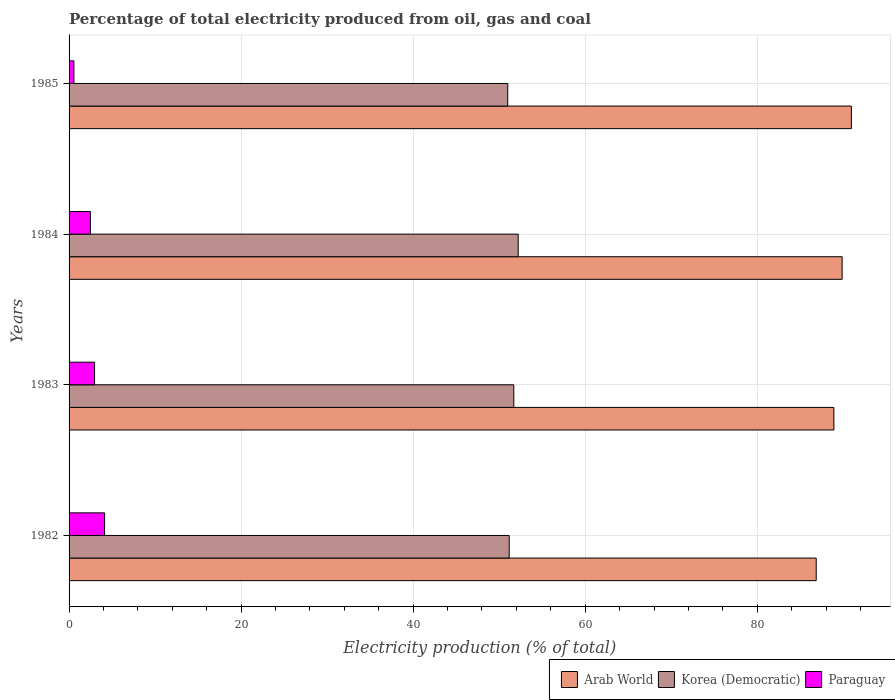How many groups of bars are there?
Give a very brief answer. 4. Are the number of bars per tick equal to the number of legend labels?
Your response must be concise. Yes. How many bars are there on the 4th tick from the bottom?
Offer a very short reply. 3. What is the label of the 4th group of bars from the top?
Make the answer very short. 1982. What is the electricity production in in Paraguay in 1982?
Give a very brief answer. 4.13. Across all years, what is the maximum electricity production in in Korea (Democratic)?
Give a very brief answer. 52.21. Across all years, what is the minimum electricity production in in Paraguay?
Make the answer very short. 0.56. In which year was the electricity production in in Arab World maximum?
Provide a succinct answer. 1985. In which year was the electricity production in in Paraguay minimum?
Provide a succinct answer. 1985. What is the total electricity production in in Paraguay in the graph?
Offer a very short reply. 10.14. What is the difference between the electricity production in in Korea (Democratic) in 1984 and that in 1985?
Offer a very short reply. 1.21. What is the difference between the electricity production in in Korea (Democratic) in 1985 and the electricity production in in Arab World in 1984?
Make the answer very short. -38.87. What is the average electricity production in in Korea (Democratic) per year?
Provide a succinct answer. 51.52. In the year 1985, what is the difference between the electricity production in in Arab World and electricity production in in Paraguay?
Provide a short and direct response. 90.38. In how many years, is the electricity production in in Arab World greater than 12 %?
Provide a succinct answer. 4. What is the ratio of the electricity production in in Arab World in 1983 to that in 1984?
Offer a very short reply. 0.99. What is the difference between the highest and the second highest electricity production in in Korea (Democratic)?
Provide a succinct answer. 0.51. What is the difference between the highest and the lowest electricity production in in Arab World?
Your response must be concise. 4.09. In how many years, is the electricity production in in Arab World greater than the average electricity production in in Arab World taken over all years?
Your answer should be very brief. 2. Is the sum of the electricity production in in Korea (Democratic) in 1984 and 1985 greater than the maximum electricity production in in Paraguay across all years?
Give a very brief answer. Yes. What does the 3rd bar from the top in 1985 represents?
Offer a very short reply. Arab World. What does the 3rd bar from the bottom in 1984 represents?
Your answer should be very brief. Paraguay. Is it the case that in every year, the sum of the electricity production in in Korea (Democratic) and electricity production in in Arab World is greater than the electricity production in in Paraguay?
Your response must be concise. Yes. Are all the bars in the graph horizontal?
Provide a succinct answer. Yes. How many years are there in the graph?
Give a very brief answer. 4. Are the values on the major ticks of X-axis written in scientific E-notation?
Keep it short and to the point. No. Where does the legend appear in the graph?
Provide a short and direct response. Bottom right. How many legend labels are there?
Your response must be concise. 3. What is the title of the graph?
Ensure brevity in your answer.  Percentage of total electricity produced from oil, gas and coal. Does "Fiji" appear as one of the legend labels in the graph?
Keep it short and to the point. No. What is the label or title of the X-axis?
Ensure brevity in your answer.  Electricity production (% of total). What is the label or title of the Y-axis?
Make the answer very short. Years. What is the Electricity production (% of total) of Arab World in 1982?
Keep it short and to the point. 86.85. What is the Electricity production (% of total) of Korea (Democratic) in 1982?
Give a very brief answer. 51.16. What is the Electricity production (% of total) in Paraguay in 1982?
Keep it short and to the point. 4.13. What is the Electricity production (% of total) in Arab World in 1983?
Make the answer very short. 88.91. What is the Electricity production (% of total) in Korea (Democratic) in 1983?
Offer a very short reply. 51.7. What is the Electricity production (% of total) in Paraguay in 1983?
Offer a terse response. 2.97. What is the Electricity production (% of total) in Arab World in 1984?
Give a very brief answer. 89.87. What is the Electricity production (% of total) in Korea (Democratic) in 1984?
Ensure brevity in your answer.  52.21. What is the Electricity production (% of total) in Paraguay in 1984?
Make the answer very short. 2.48. What is the Electricity production (% of total) of Arab World in 1985?
Make the answer very short. 90.94. What is the Electricity production (% of total) of Korea (Democratic) in 1985?
Keep it short and to the point. 51. What is the Electricity production (% of total) in Paraguay in 1985?
Ensure brevity in your answer.  0.56. Across all years, what is the maximum Electricity production (% of total) of Arab World?
Provide a succinct answer. 90.94. Across all years, what is the maximum Electricity production (% of total) of Korea (Democratic)?
Give a very brief answer. 52.21. Across all years, what is the maximum Electricity production (% of total) of Paraguay?
Make the answer very short. 4.13. Across all years, what is the minimum Electricity production (% of total) of Arab World?
Provide a short and direct response. 86.85. Across all years, what is the minimum Electricity production (% of total) in Korea (Democratic)?
Make the answer very short. 51. Across all years, what is the minimum Electricity production (% of total) of Paraguay?
Your answer should be compact. 0.56. What is the total Electricity production (% of total) in Arab World in the graph?
Your answer should be very brief. 356.57. What is the total Electricity production (% of total) of Korea (Democratic) in the graph?
Give a very brief answer. 206.07. What is the total Electricity production (% of total) of Paraguay in the graph?
Offer a very short reply. 10.14. What is the difference between the Electricity production (% of total) of Arab World in 1982 and that in 1983?
Your response must be concise. -2.05. What is the difference between the Electricity production (% of total) of Korea (Democratic) in 1982 and that in 1983?
Provide a succinct answer. -0.54. What is the difference between the Electricity production (% of total) in Paraguay in 1982 and that in 1983?
Offer a very short reply. 1.17. What is the difference between the Electricity production (% of total) of Arab World in 1982 and that in 1984?
Make the answer very short. -3.01. What is the difference between the Electricity production (% of total) in Korea (Democratic) in 1982 and that in 1984?
Provide a short and direct response. -1.05. What is the difference between the Electricity production (% of total) of Paraguay in 1982 and that in 1984?
Your response must be concise. 1.65. What is the difference between the Electricity production (% of total) of Arab World in 1982 and that in 1985?
Your answer should be very brief. -4.09. What is the difference between the Electricity production (% of total) in Korea (Democratic) in 1982 and that in 1985?
Provide a short and direct response. 0.17. What is the difference between the Electricity production (% of total) in Paraguay in 1982 and that in 1985?
Your answer should be very brief. 3.57. What is the difference between the Electricity production (% of total) in Arab World in 1983 and that in 1984?
Offer a very short reply. -0.96. What is the difference between the Electricity production (% of total) in Korea (Democratic) in 1983 and that in 1984?
Your response must be concise. -0.51. What is the difference between the Electricity production (% of total) in Paraguay in 1983 and that in 1984?
Your answer should be compact. 0.49. What is the difference between the Electricity production (% of total) of Arab World in 1983 and that in 1985?
Ensure brevity in your answer.  -2.03. What is the difference between the Electricity production (% of total) of Korea (Democratic) in 1983 and that in 1985?
Keep it short and to the point. 0.7. What is the difference between the Electricity production (% of total) in Paraguay in 1983 and that in 1985?
Offer a very short reply. 2.4. What is the difference between the Electricity production (% of total) in Arab World in 1984 and that in 1985?
Your answer should be very brief. -1.08. What is the difference between the Electricity production (% of total) of Korea (Democratic) in 1984 and that in 1985?
Offer a very short reply. 1.21. What is the difference between the Electricity production (% of total) of Paraguay in 1984 and that in 1985?
Your response must be concise. 1.92. What is the difference between the Electricity production (% of total) in Arab World in 1982 and the Electricity production (% of total) in Korea (Democratic) in 1983?
Offer a very short reply. 35.15. What is the difference between the Electricity production (% of total) in Arab World in 1982 and the Electricity production (% of total) in Paraguay in 1983?
Your response must be concise. 83.89. What is the difference between the Electricity production (% of total) of Korea (Democratic) in 1982 and the Electricity production (% of total) of Paraguay in 1983?
Ensure brevity in your answer.  48.2. What is the difference between the Electricity production (% of total) in Arab World in 1982 and the Electricity production (% of total) in Korea (Democratic) in 1984?
Offer a terse response. 34.64. What is the difference between the Electricity production (% of total) of Arab World in 1982 and the Electricity production (% of total) of Paraguay in 1984?
Offer a terse response. 84.38. What is the difference between the Electricity production (% of total) in Korea (Democratic) in 1982 and the Electricity production (% of total) in Paraguay in 1984?
Make the answer very short. 48.68. What is the difference between the Electricity production (% of total) of Arab World in 1982 and the Electricity production (% of total) of Korea (Democratic) in 1985?
Your answer should be compact. 35.86. What is the difference between the Electricity production (% of total) of Arab World in 1982 and the Electricity production (% of total) of Paraguay in 1985?
Offer a very short reply. 86.29. What is the difference between the Electricity production (% of total) of Korea (Democratic) in 1982 and the Electricity production (% of total) of Paraguay in 1985?
Provide a short and direct response. 50.6. What is the difference between the Electricity production (% of total) in Arab World in 1983 and the Electricity production (% of total) in Korea (Democratic) in 1984?
Ensure brevity in your answer.  36.7. What is the difference between the Electricity production (% of total) in Arab World in 1983 and the Electricity production (% of total) in Paraguay in 1984?
Make the answer very short. 86.43. What is the difference between the Electricity production (% of total) of Korea (Democratic) in 1983 and the Electricity production (% of total) of Paraguay in 1984?
Offer a terse response. 49.22. What is the difference between the Electricity production (% of total) in Arab World in 1983 and the Electricity production (% of total) in Korea (Democratic) in 1985?
Make the answer very short. 37.91. What is the difference between the Electricity production (% of total) in Arab World in 1983 and the Electricity production (% of total) in Paraguay in 1985?
Give a very brief answer. 88.35. What is the difference between the Electricity production (% of total) of Korea (Democratic) in 1983 and the Electricity production (% of total) of Paraguay in 1985?
Give a very brief answer. 51.14. What is the difference between the Electricity production (% of total) of Arab World in 1984 and the Electricity production (% of total) of Korea (Democratic) in 1985?
Your answer should be very brief. 38.87. What is the difference between the Electricity production (% of total) in Arab World in 1984 and the Electricity production (% of total) in Paraguay in 1985?
Your answer should be very brief. 89.3. What is the difference between the Electricity production (% of total) of Korea (Democratic) in 1984 and the Electricity production (% of total) of Paraguay in 1985?
Give a very brief answer. 51.65. What is the average Electricity production (% of total) of Arab World per year?
Your response must be concise. 89.14. What is the average Electricity production (% of total) of Korea (Democratic) per year?
Your response must be concise. 51.52. What is the average Electricity production (% of total) of Paraguay per year?
Ensure brevity in your answer.  2.53. In the year 1982, what is the difference between the Electricity production (% of total) of Arab World and Electricity production (% of total) of Korea (Democratic)?
Make the answer very short. 35.69. In the year 1982, what is the difference between the Electricity production (% of total) of Arab World and Electricity production (% of total) of Paraguay?
Your response must be concise. 82.72. In the year 1982, what is the difference between the Electricity production (% of total) in Korea (Democratic) and Electricity production (% of total) in Paraguay?
Give a very brief answer. 47.03. In the year 1983, what is the difference between the Electricity production (% of total) of Arab World and Electricity production (% of total) of Korea (Democratic)?
Ensure brevity in your answer.  37.21. In the year 1983, what is the difference between the Electricity production (% of total) of Arab World and Electricity production (% of total) of Paraguay?
Your answer should be very brief. 85.94. In the year 1983, what is the difference between the Electricity production (% of total) in Korea (Democratic) and Electricity production (% of total) in Paraguay?
Your answer should be very brief. 48.73. In the year 1984, what is the difference between the Electricity production (% of total) in Arab World and Electricity production (% of total) in Korea (Democratic)?
Provide a succinct answer. 37.66. In the year 1984, what is the difference between the Electricity production (% of total) in Arab World and Electricity production (% of total) in Paraguay?
Provide a short and direct response. 87.39. In the year 1984, what is the difference between the Electricity production (% of total) in Korea (Democratic) and Electricity production (% of total) in Paraguay?
Provide a succinct answer. 49.73. In the year 1985, what is the difference between the Electricity production (% of total) of Arab World and Electricity production (% of total) of Korea (Democratic)?
Keep it short and to the point. 39.95. In the year 1985, what is the difference between the Electricity production (% of total) in Arab World and Electricity production (% of total) in Paraguay?
Ensure brevity in your answer.  90.38. In the year 1985, what is the difference between the Electricity production (% of total) in Korea (Democratic) and Electricity production (% of total) in Paraguay?
Ensure brevity in your answer.  50.43. What is the ratio of the Electricity production (% of total) of Arab World in 1982 to that in 1983?
Provide a succinct answer. 0.98. What is the ratio of the Electricity production (% of total) of Korea (Democratic) in 1982 to that in 1983?
Your response must be concise. 0.99. What is the ratio of the Electricity production (% of total) in Paraguay in 1982 to that in 1983?
Offer a very short reply. 1.39. What is the ratio of the Electricity production (% of total) of Arab World in 1982 to that in 1984?
Ensure brevity in your answer.  0.97. What is the ratio of the Electricity production (% of total) of Korea (Democratic) in 1982 to that in 1984?
Give a very brief answer. 0.98. What is the ratio of the Electricity production (% of total) of Paraguay in 1982 to that in 1984?
Your answer should be very brief. 1.67. What is the ratio of the Electricity production (% of total) in Arab World in 1982 to that in 1985?
Provide a short and direct response. 0.96. What is the ratio of the Electricity production (% of total) in Korea (Democratic) in 1982 to that in 1985?
Your answer should be compact. 1. What is the ratio of the Electricity production (% of total) of Paraguay in 1982 to that in 1985?
Ensure brevity in your answer.  7.34. What is the ratio of the Electricity production (% of total) of Arab World in 1983 to that in 1984?
Ensure brevity in your answer.  0.99. What is the ratio of the Electricity production (% of total) of Korea (Democratic) in 1983 to that in 1984?
Keep it short and to the point. 0.99. What is the ratio of the Electricity production (% of total) of Paraguay in 1983 to that in 1984?
Make the answer very short. 1.2. What is the ratio of the Electricity production (% of total) in Arab World in 1983 to that in 1985?
Make the answer very short. 0.98. What is the ratio of the Electricity production (% of total) in Korea (Democratic) in 1983 to that in 1985?
Give a very brief answer. 1.01. What is the ratio of the Electricity production (% of total) of Paraguay in 1983 to that in 1985?
Your answer should be very brief. 5.27. What is the ratio of the Electricity production (% of total) in Arab World in 1984 to that in 1985?
Make the answer very short. 0.99. What is the ratio of the Electricity production (% of total) in Korea (Democratic) in 1984 to that in 1985?
Provide a short and direct response. 1.02. What is the ratio of the Electricity production (% of total) in Paraguay in 1984 to that in 1985?
Provide a succinct answer. 4.41. What is the difference between the highest and the second highest Electricity production (% of total) of Arab World?
Your answer should be very brief. 1.08. What is the difference between the highest and the second highest Electricity production (% of total) of Korea (Democratic)?
Your answer should be compact. 0.51. What is the difference between the highest and the second highest Electricity production (% of total) of Paraguay?
Ensure brevity in your answer.  1.17. What is the difference between the highest and the lowest Electricity production (% of total) in Arab World?
Offer a very short reply. 4.09. What is the difference between the highest and the lowest Electricity production (% of total) in Korea (Democratic)?
Keep it short and to the point. 1.21. What is the difference between the highest and the lowest Electricity production (% of total) in Paraguay?
Give a very brief answer. 3.57. 